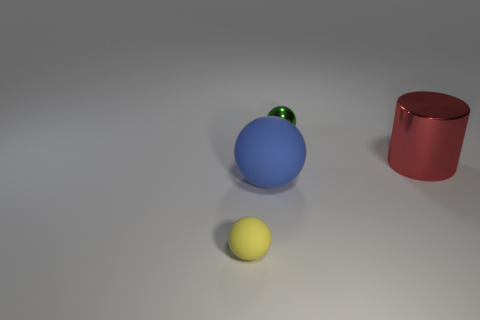Is there anything in the image that indicates its scale or the size of the objects? There are no definitive references in the image to accurately determine scale or the precise size of the objects. The sizes are relative to each other, with the blue sphere being the largest, the red cylinder smaller, and the yellow sphere the smallest visible object. 